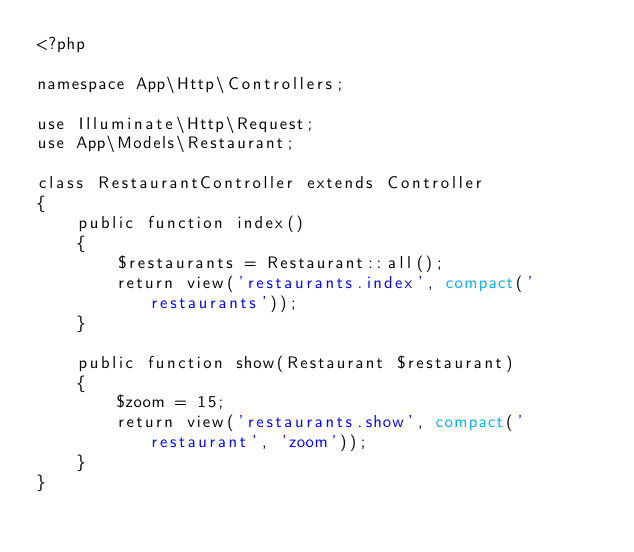Convert code to text. <code><loc_0><loc_0><loc_500><loc_500><_PHP_><?php

namespace App\Http\Controllers;

use Illuminate\Http\Request;
use App\Models\Restaurant;

class RestaurantController extends Controller
{
    public function index()
    {
        $restaurants = Restaurant::all();
        return view('restaurants.index', compact('restaurants'));
    }

    public function show(Restaurant $restaurant)
    {
        $zoom = 15;
        return view('restaurants.show', compact('restaurant', 'zoom'));
    }
}
</code> 